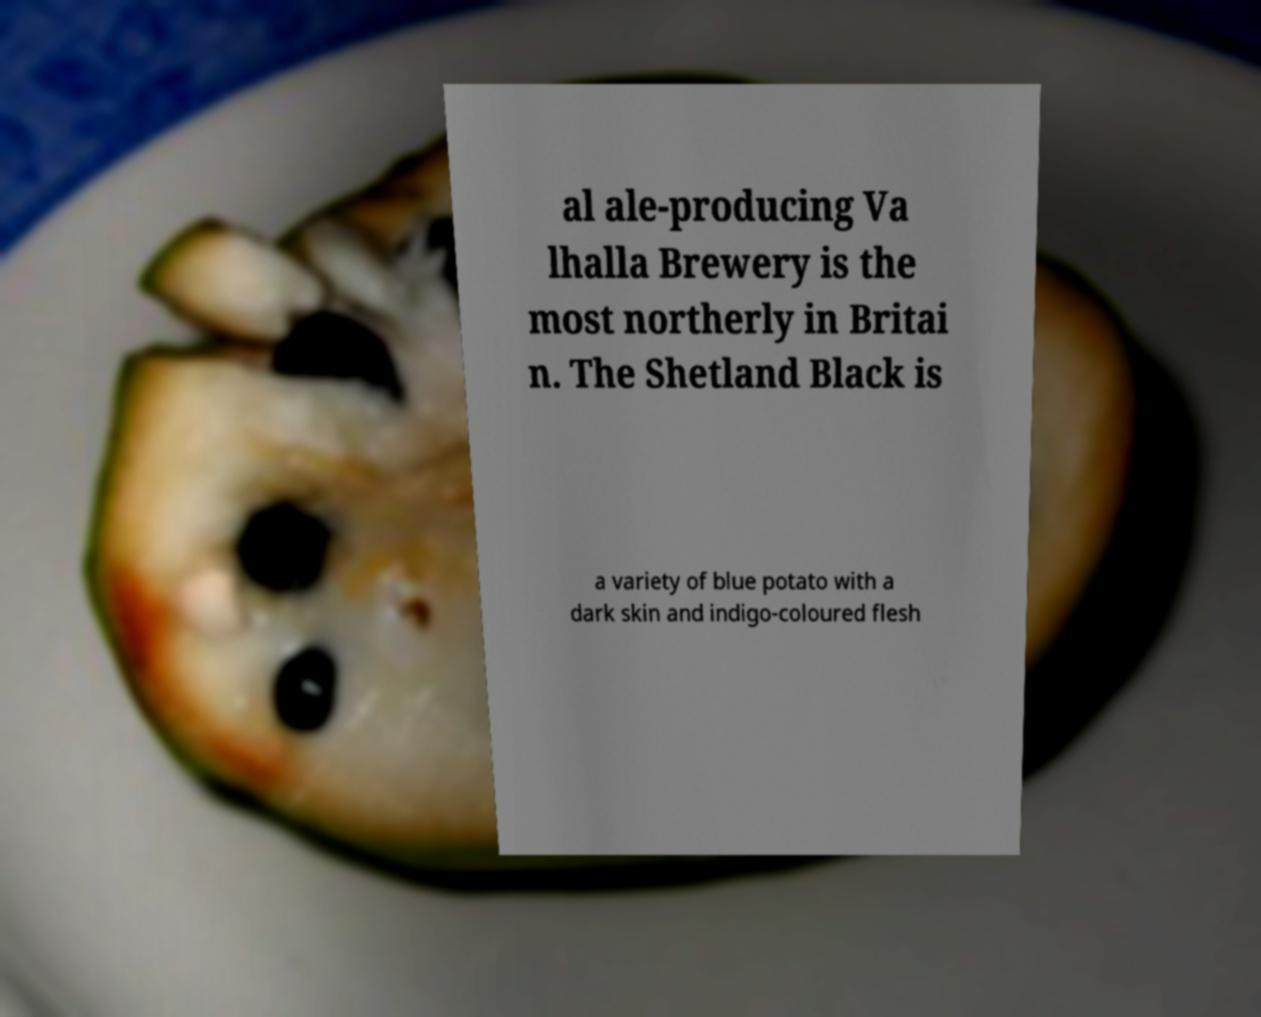Could you extract and type out the text from this image? al ale-producing Va lhalla Brewery is the most northerly in Britai n. The Shetland Black is a variety of blue potato with a dark skin and indigo-coloured flesh 